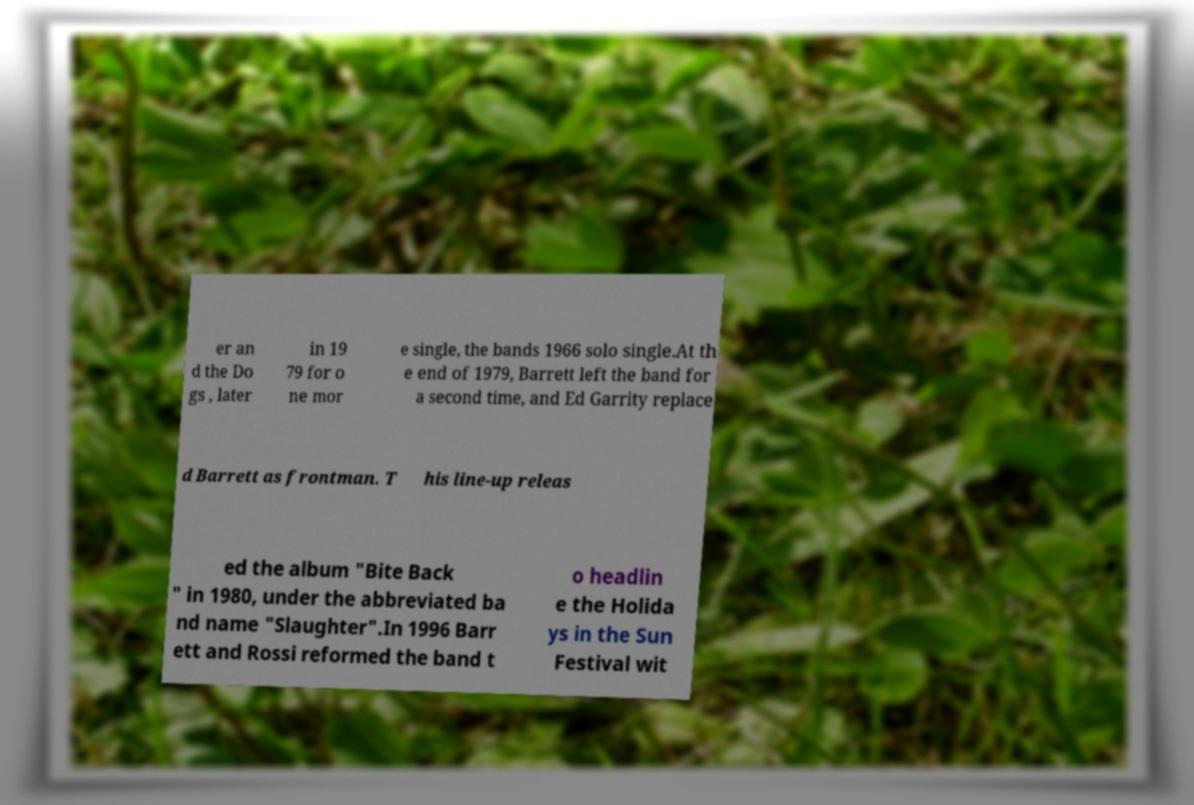There's text embedded in this image that I need extracted. Can you transcribe it verbatim? er an d the Do gs , later in 19 79 for o ne mor e single, the bands 1966 solo single.At th e end of 1979, Barrett left the band for a second time, and Ed Garrity replace d Barrett as frontman. T his line-up releas ed the album "Bite Back " in 1980, under the abbreviated ba nd name "Slaughter".In 1996 Barr ett and Rossi reformed the band t o headlin e the Holida ys in the Sun Festival wit 